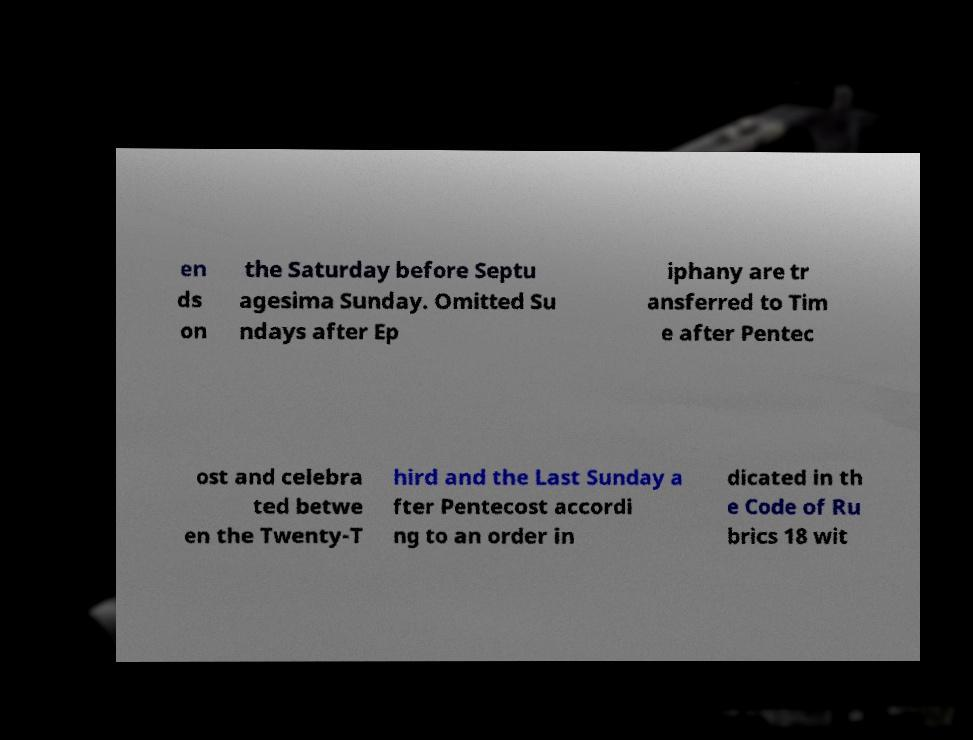Please identify and transcribe the text found in this image. en ds on the Saturday before Septu agesima Sunday. Omitted Su ndays after Ep iphany are tr ansferred to Tim e after Pentec ost and celebra ted betwe en the Twenty-T hird and the Last Sunday a fter Pentecost accordi ng to an order in dicated in th e Code of Ru brics 18 wit 